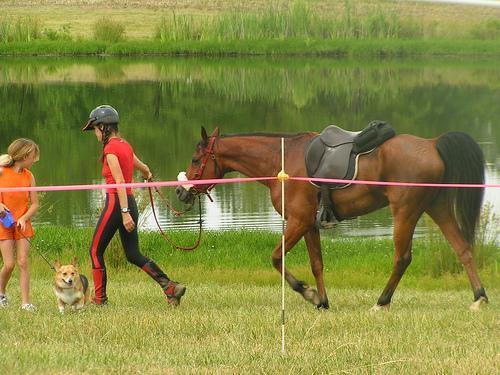How many people in the photo?
Give a very brief answer. 2. How many people can you see?
Give a very brief answer. 2. 